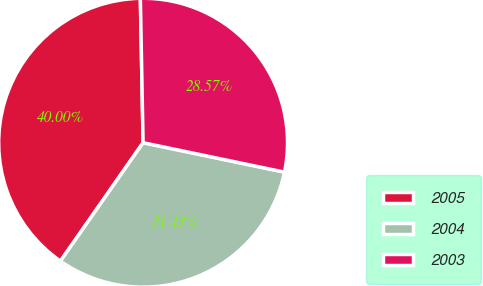Convert chart. <chart><loc_0><loc_0><loc_500><loc_500><pie_chart><fcel>2005<fcel>2004<fcel>2003<nl><fcel>40.0%<fcel>31.43%<fcel>28.57%<nl></chart> 